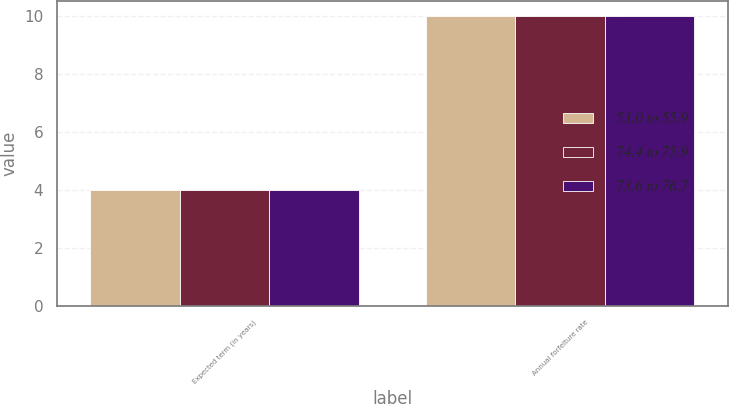Convert chart. <chart><loc_0><loc_0><loc_500><loc_500><stacked_bar_chart><ecel><fcel>Expected term (in years)<fcel>Annual forfeiture rate<nl><fcel>53.0 to 55.9<fcel>4<fcel>10<nl><fcel>74.4 to 75.9<fcel>4<fcel>10<nl><fcel>73.6 to 76.7<fcel>4<fcel>10<nl></chart> 